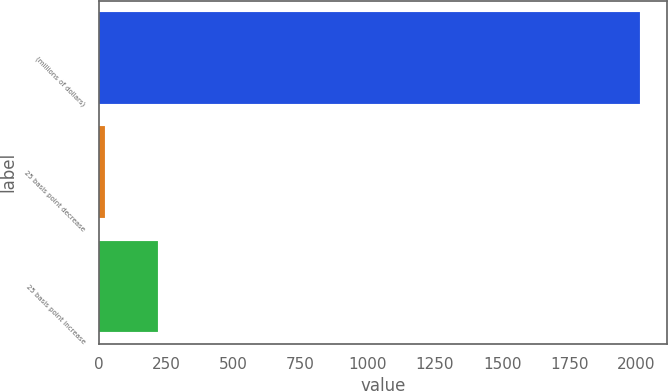Convert chart. <chart><loc_0><loc_0><loc_500><loc_500><bar_chart><fcel>(millions of dollars)<fcel>25 basis point decrease<fcel>25 basis point increase<nl><fcel>2014<fcel>20.8<fcel>220.12<nl></chart> 